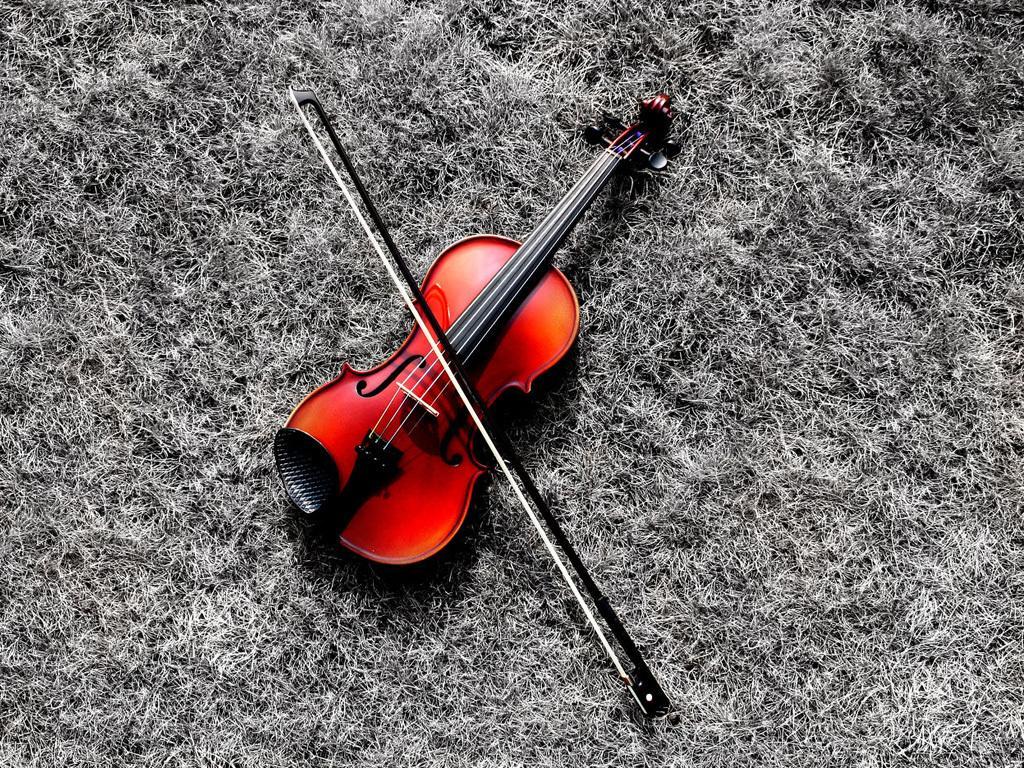Could you give a brief overview of what you see in this image? In a given image I can see a musical instrument. 